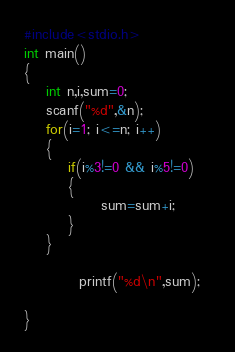Convert code to text. <code><loc_0><loc_0><loc_500><loc_500><_C_>#include<stdio.h>
int main()
{
    int n,i,sum=0;
    scanf("%d",&n);
    for(i=1; i<=n; i++)
    {
        if(i%3!=0 && i%5!=0)
        {
              sum=sum+i;
        }
    }
         
          printf("%d\n",sum);  
  
}
</code> 